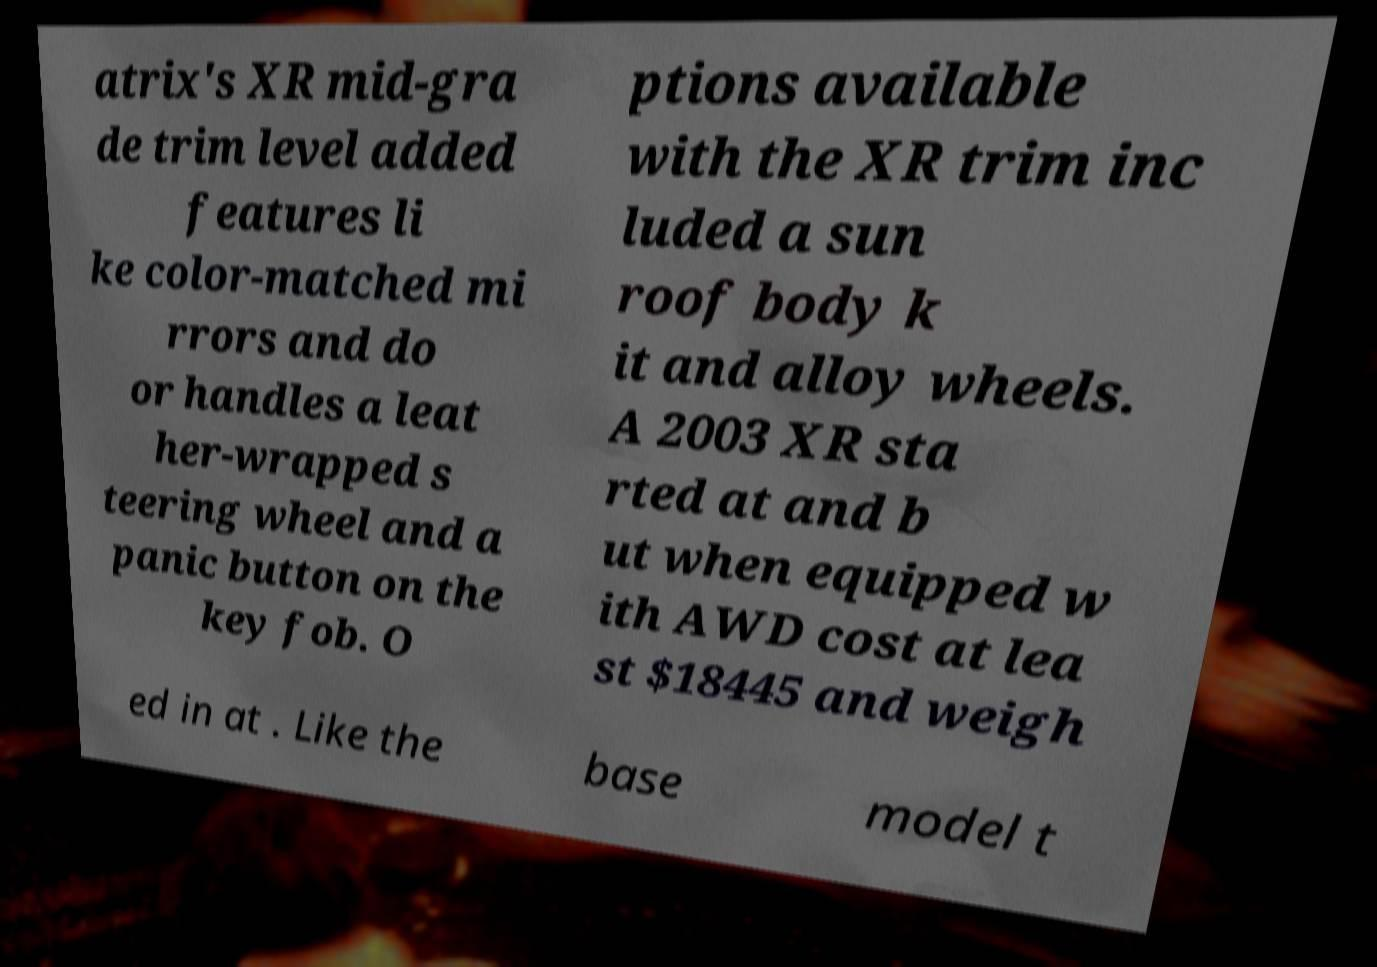Could you assist in decoding the text presented in this image and type it out clearly? atrix's XR mid-gra de trim level added features li ke color-matched mi rrors and do or handles a leat her-wrapped s teering wheel and a panic button on the key fob. O ptions available with the XR trim inc luded a sun roof body k it and alloy wheels. A 2003 XR sta rted at and b ut when equipped w ith AWD cost at lea st $18445 and weigh ed in at . Like the base model t 